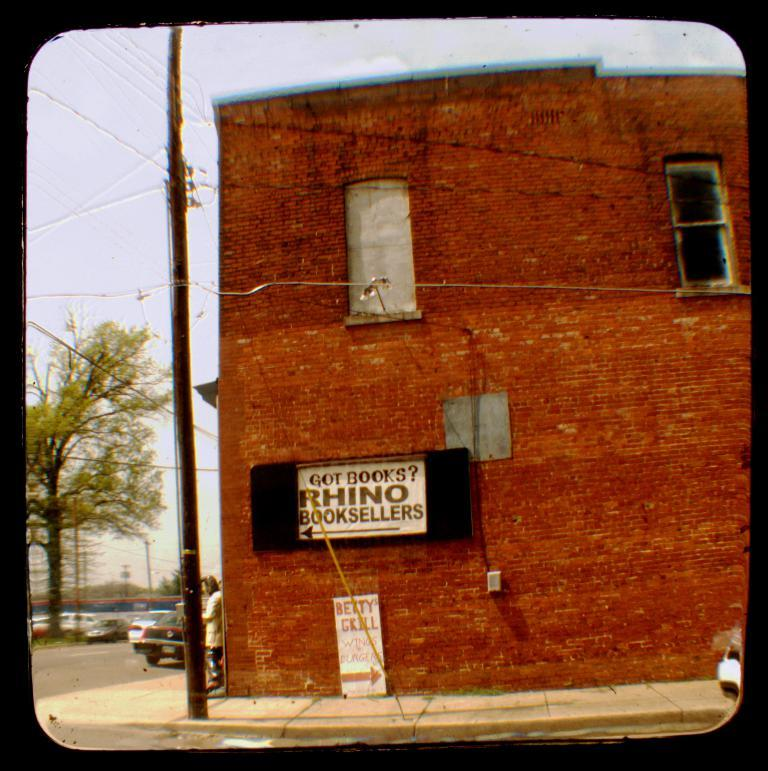What type of structure is present in the image? There is a building in the image. What else can be seen in the image besides the building? There are vehicles, poles, wires, trees, boards with text, and a person visible in the image. What is the purpose of the poles in the image? The poles are likely used to support the wires in the image. What can be seen in the background of the image? The sky is visible in the background of the image. What type of pickle is the person holding in the image? There is no pickle present in the image; the person is not holding any object. What is the person doing with the pipe in the image? There is no pipe present in the image; the person is not interacting with any object. 